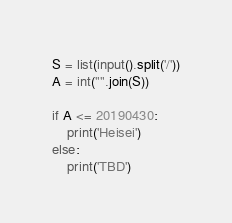Convert code to text. <code><loc_0><loc_0><loc_500><loc_500><_Python_>S = list(input().split('/'))
A = int("".join(S))

if A <= 20190430:
    print('Heisei')
else:
    print('TBD')
</code> 